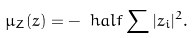Convert formula to latex. <formula><loc_0><loc_0><loc_500><loc_500>\mu _ { Z } ( z ) = - \ h a l f \sum | z _ { i } | ^ { 2 } .</formula> 